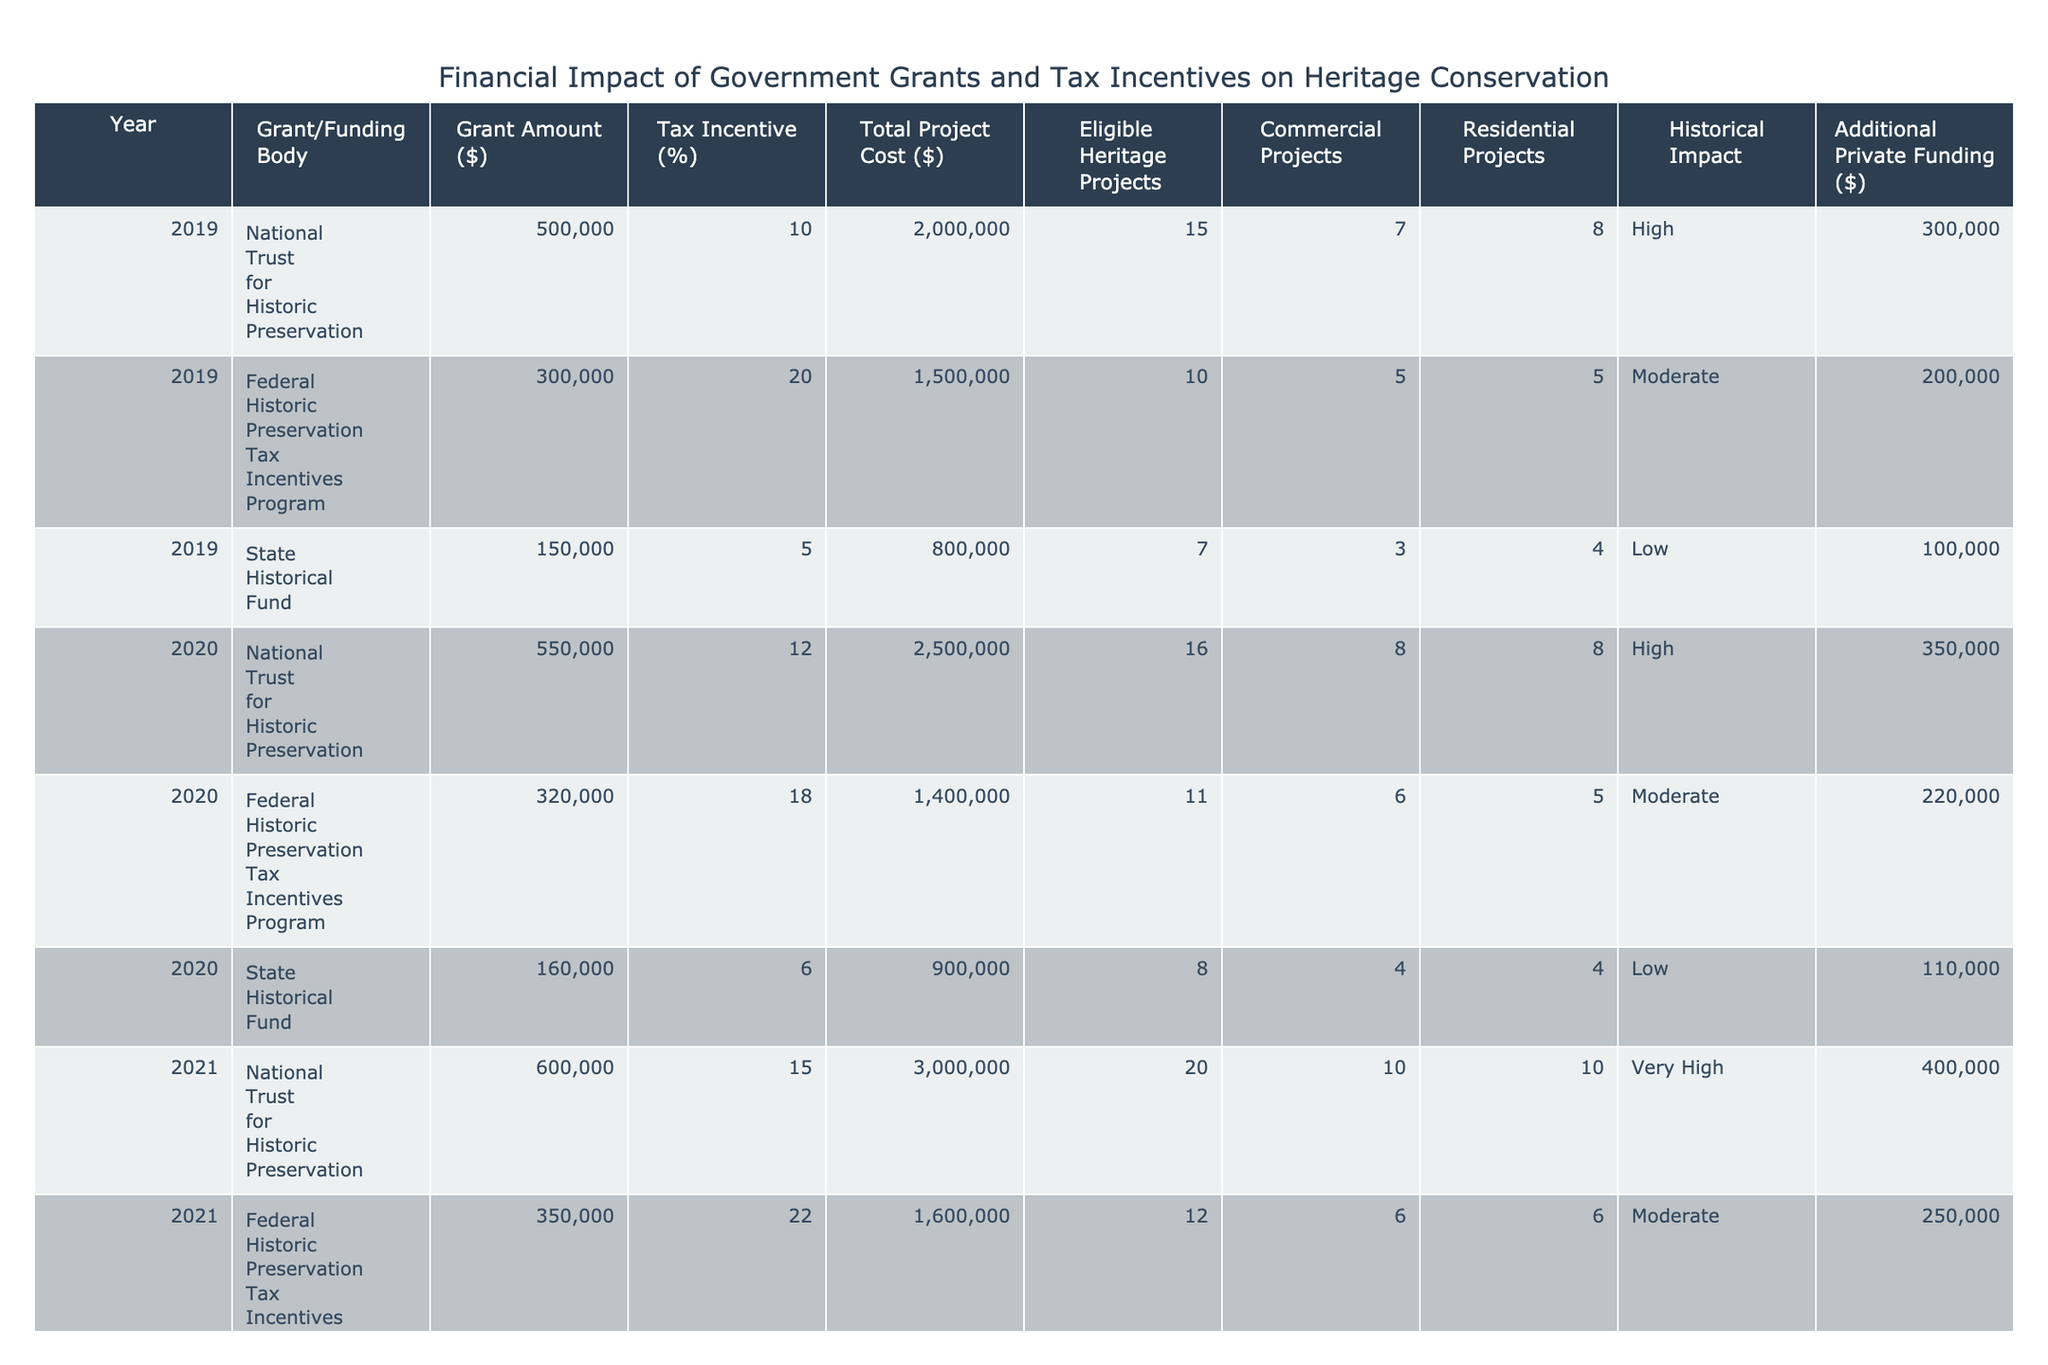What was the total grant amount received in 2021? To find the total grant amount for 2021, we look at the rows corresponding to that year: National Trust for Historic Preservation received 600000, Federal Historic Preservation Tax Incentives Program received 350000, and State Historical Fund received 170000. Adding these values gives 600000 + 350000 + 170000 = 1120000.
Answer: 1120000 What is the average tax incentive percentage across all years? To calculate the average, add all the tax incentive percentages: 10 + 20 + 5 + 12 + 18 + 6 + 15 + 22 + 8 + 15 + 25 + 30 + 12 =  273. There are 13 entries, so divide by 13: 273 / 13 = 21.0.
Answer: 21.0 Did the total project cost increase from 2020 to 2021? The total project cost for 2020 is 2500000, and for 2021 it is 3000000. Since 3000000 is greater than 2500000, it indicates an increase in total project cost.
Answer: Yes Which funding body provided the highest individual grant amount in 2023? In 2023, National Trust for Historic Preservation provided a grant of 700000, Federal Historic Preservation Tax Incentives Program provided 400000, and State Historical Fund provided 200000. The highest amount is 700000 from National Trust for Historic Preservation.
Answer: National Trust for Historic Preservation What is the total additional private funding across all projects in 2022? The additional private funding for 2022 is: 450000 from National Trust for Historic Preservation, 280000 from Federal Historic Preservation Tax Incentives Program, and 130000 from State Historical Fund. Adding these gives 450000 + 280000 + 130000 = 860000.
Answer: 860000 Which year had the most eligible heritage projects? Looking at the eligible heritage projects, 2023 had 25 projects, 2022 had 22, 2021 had 20, 2020 had 16, and 2019 had 15. The highest number of eligible heritage projects occurred in 2023.
Answer: 2023 What was the ratio of residential to commercial projects in 2020? In 2020, there were 8 residential projects and 8 commercial projects. The ratio of residential to commercial projects can be calculated by dividing the number of residential projects by the number of commercial projects: 8 / 8 = 1:1.
Answer: 1:1 What is the total grant amount and additional private funding combined for all years? The total grant amount across all years is calculated by summing up all individual grant amounts, which equals 500000 + 300000 + 150000 + 550000 + 320000 + 160000 + 600000 + 350000 + 170000 + 650000 + 370000 + 180000 + 700000 + 400000 + 200000 = 5030000. The additional private funding sums up to: 300000 + 200000 + 100000 + 350000 + 220000 + 110000 + 400000 + 250000 + 120000 + 450000 + 280000 + 130000 + 500000 + 300000 + 150000 = 4530000. Combining both sums, we get 5030000 + 4530000 = 9560000.
Answer: 9560000 Was there a noticeable trend in historical impact rating from 2019 to 2023? When reviewing the historical impact ratings from 2019 to 2023, the ratings have evolved from High (2019) to Very High in multiple years (2021, 2022, 2023), indicating an overall upward trend in the perceived historical impact over these years.
Answer: Yes 